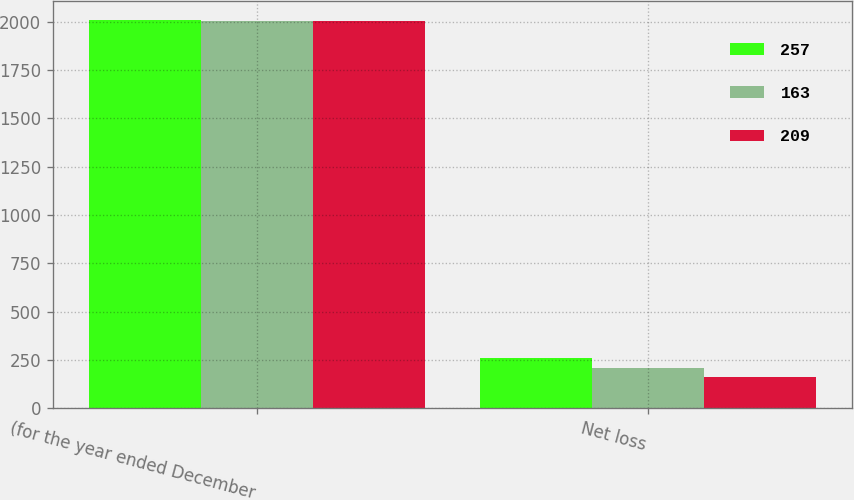Convert chart. <chart><loc_0><loc_0><loc_500><loc_500><stacked_bar_chart><ecel><fcel>(for the year ended December<fcel>Net loss<nl><fcel>257<fcel>2008<fcel>257<nl><fcel>163<fcel>2007<fcel>209<nl><fcel>209<fcel>2006<fcel>163<nl></chart> 